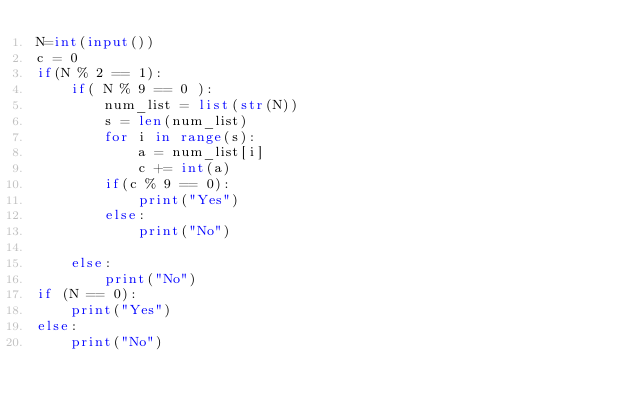Convert code to text. <code><loc_0><loc_0><loc_500><loc_500><_Python_>N=int(input())
c = 0
if(N % 2 == 1):
    if( N % 9 == 0 ):
        num_list = list(str(N))
        s = len(num_list)
        for i in range(s):
            a = num_list[i]
            c += int(a) 
        if(c % 9 == 0):
            print("Yes")
        else:
            print("No")
    
    else:
        print("No")
if (N == 0):
    print("Yes")
else:
    print("No")</code> 